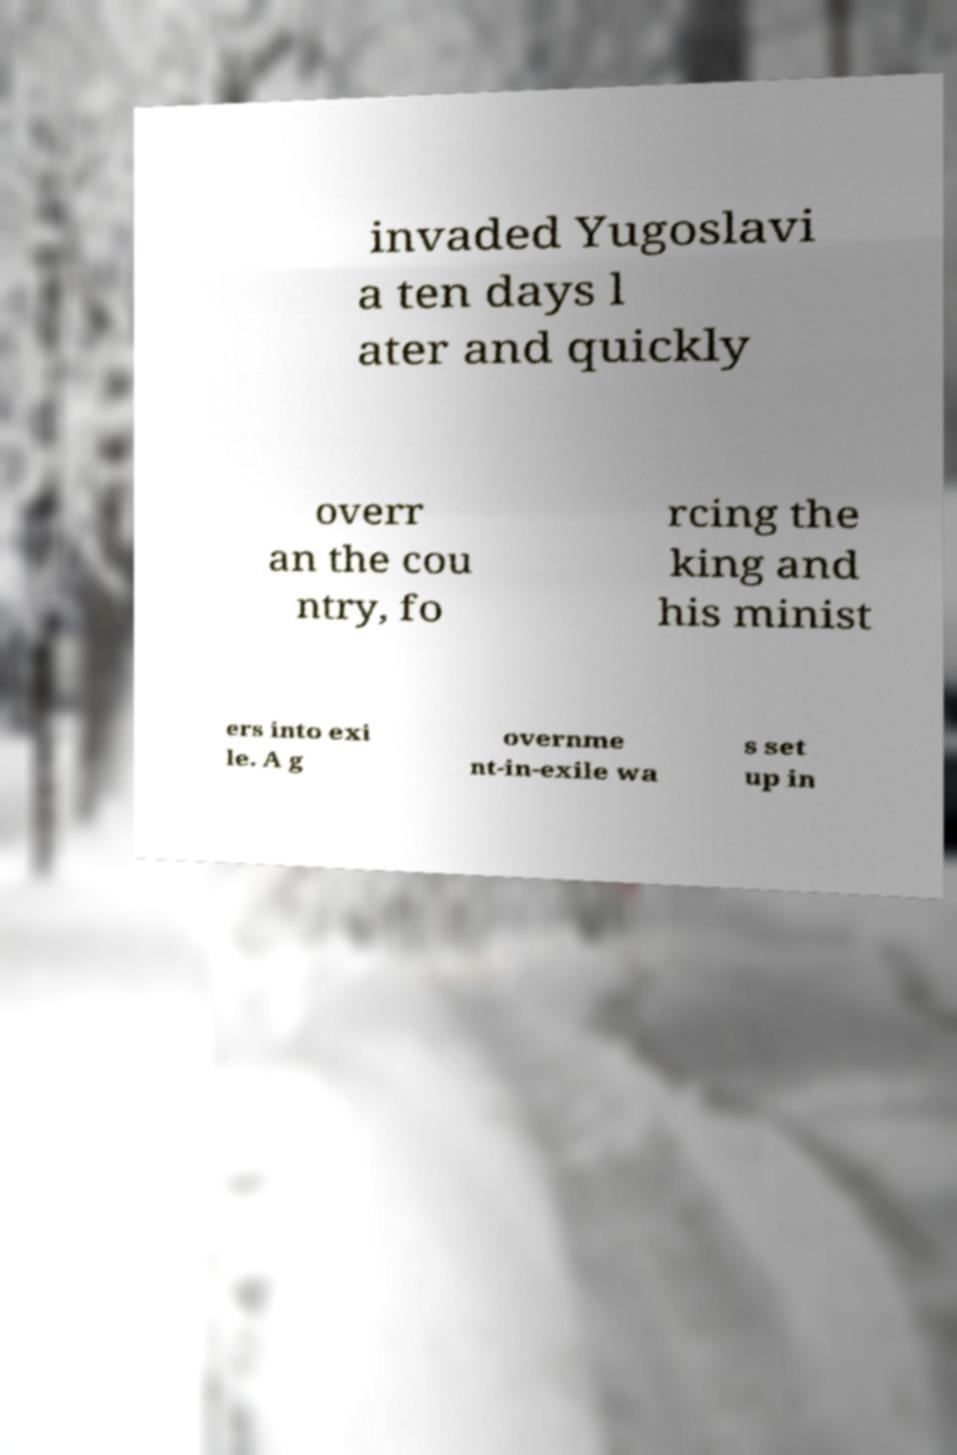Can you accurately transcribe the text from the provided image for me? invaded Yugoslavi a ten days l ater and quickly overr an the cou ntry, fo rcing the king and his minist ers into exi le. A g overnme nt-in-exile wa s set up in 